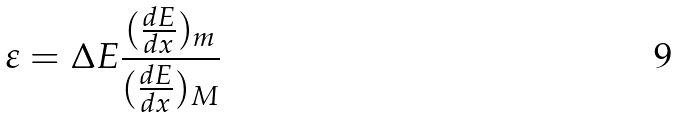<formula> <loc_0><loc_0><loc_500><loc_500>\varepsilon = { \Delta } E \frac { ( \frac { d E } { d x } ) _ { m } } { ( \frac { d E } { d x } ) _ { M } }</formula> 